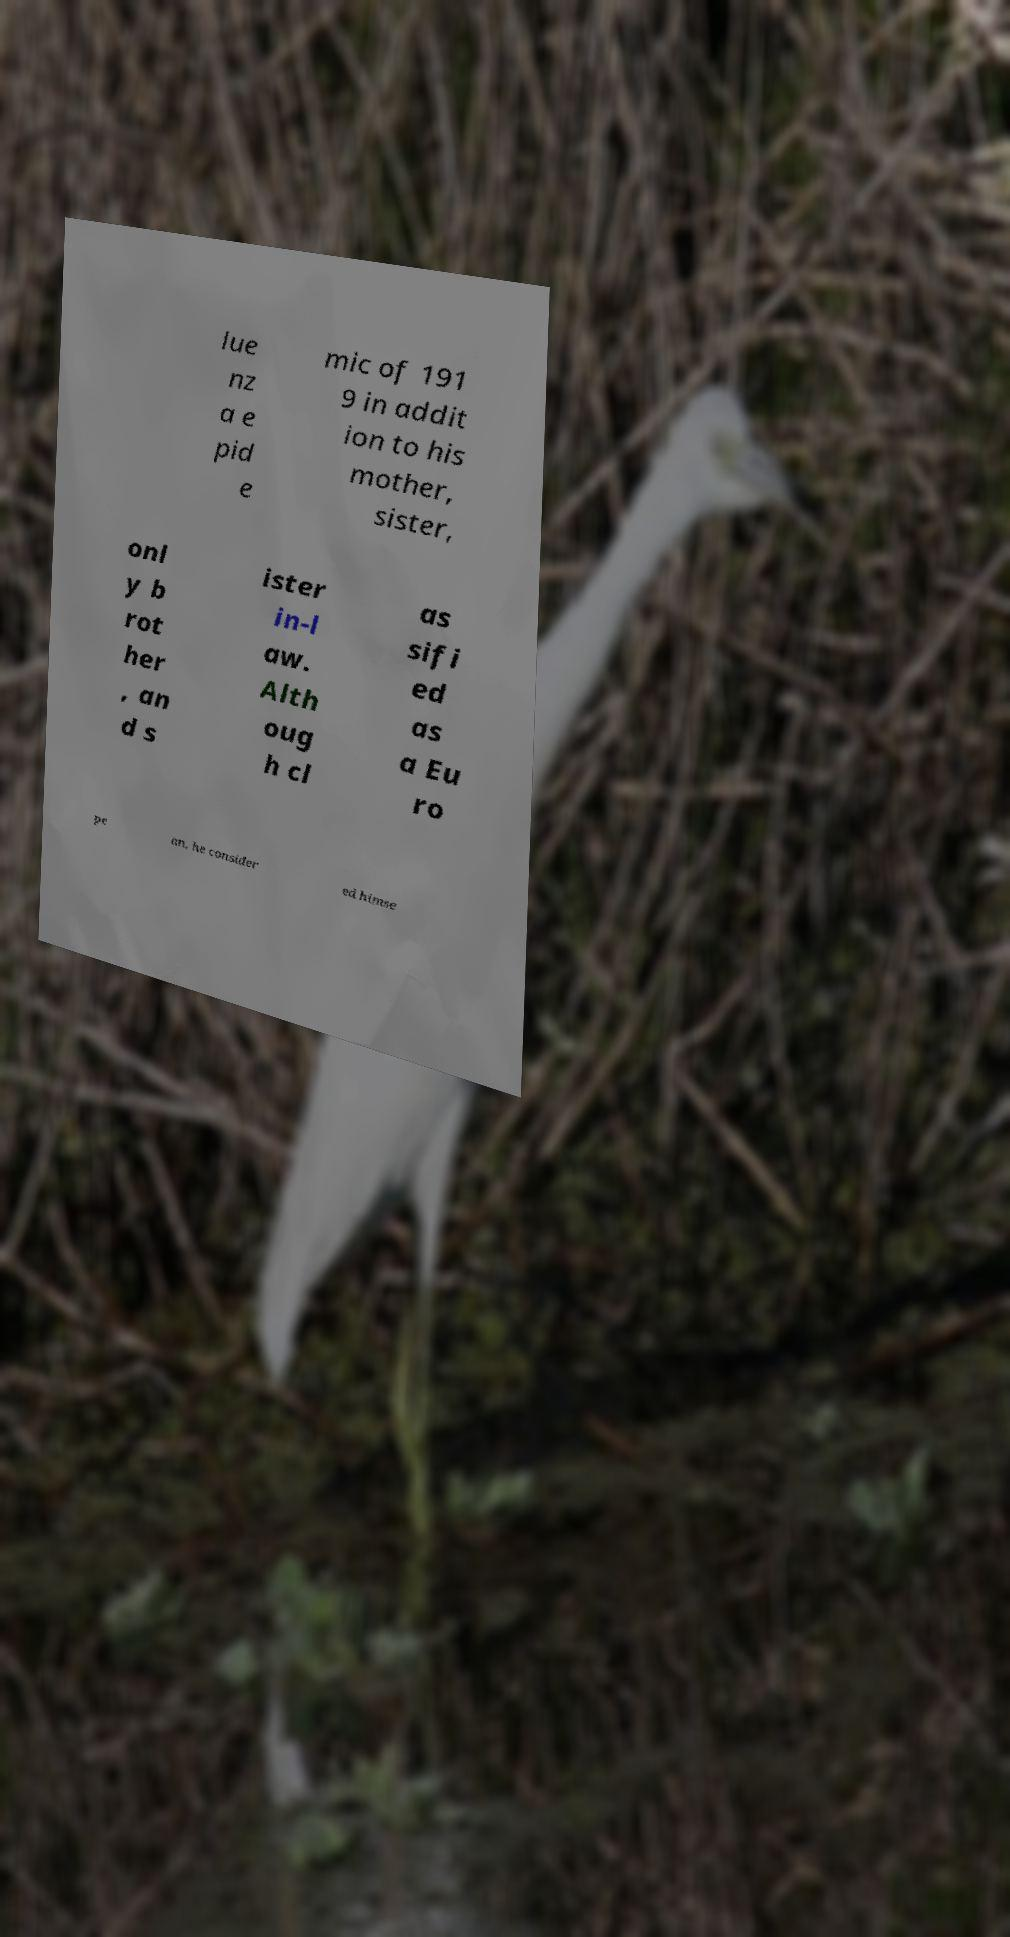Can you accurately transcribe the text from the provided image for me? lue nz a e pid e mic of 191 9 in addit ion to his mother, sister, onl y b rot her , an d s ister in-l aw. Alth oug h cl as sifi ed as a Eu ro pe an, he consider ed himse 